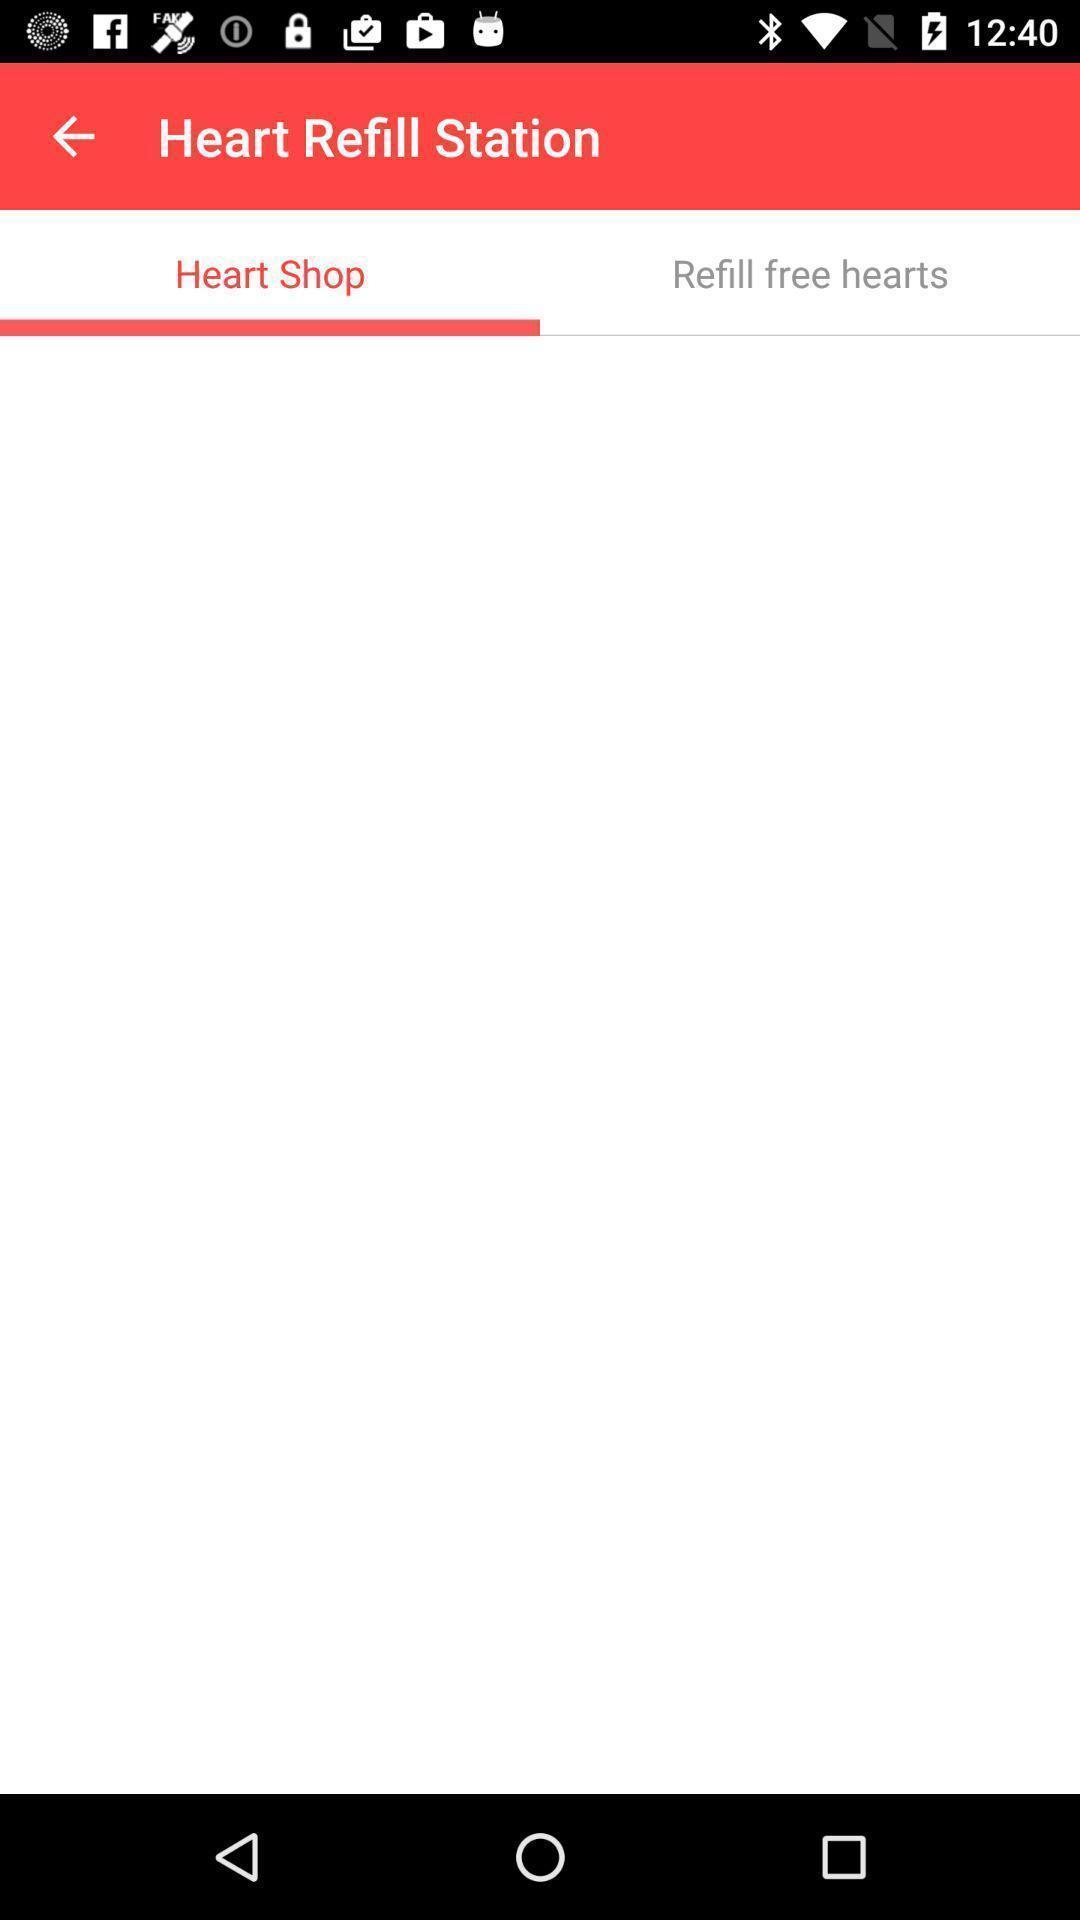Provide a description of this screenshot. Page showing application to share photos and videos. 